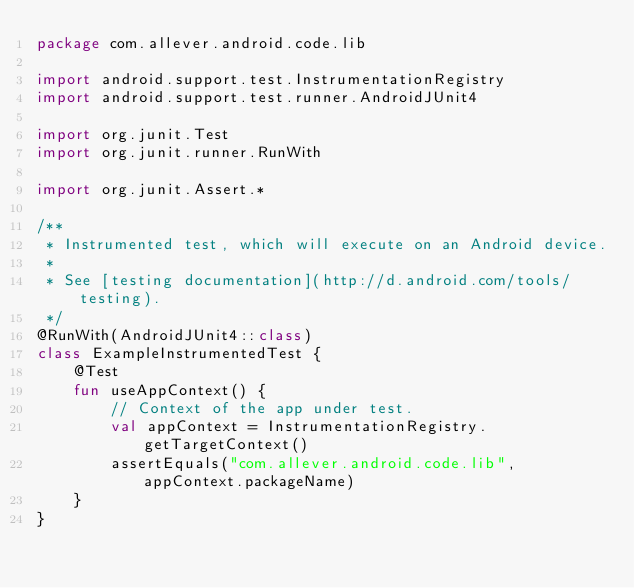Convert code to text. <code><loc_0><loc_0><loc_500><loc_500><_Kotlin_>package com.allever.android.code.lib

import android.support.test.InstrumentationRegistry
import android.support.test.runner.AndroidJUnit4

import org.junit.Test
import org.junit.runner.RunWith

import org.junit.Assert.*

/**
 * Instrumented test, which will execute on an Android device.
 *
 * See [testing documentation](http://d.android.com/tools/testing).
 */
@RunWith(AndroidJUnit4::class)
class ExampleInstrumentedTest {
    @Test
    fun useAppContext() {
        // Context of the app under test.
        val appContext = InstrumentationRegistry.getTargetContext()
        assertEquals("com.allever.android.code.lib", appContext.packageName)
    }
}
</code> 